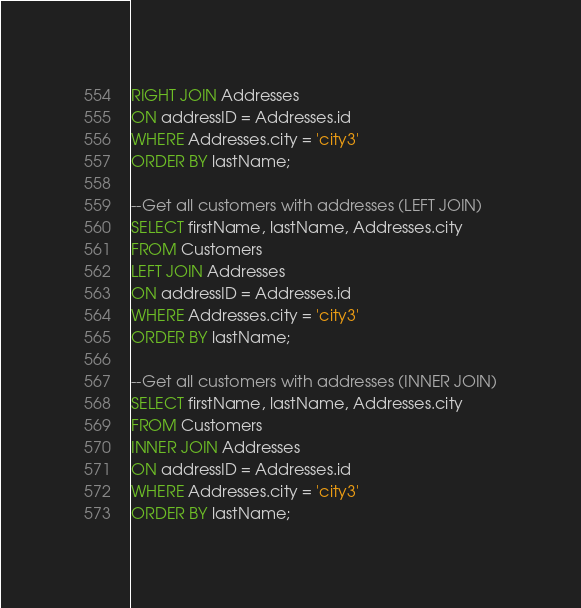Convert code to text. <code><loc_0><loc_0><loc_500><loc_500><_SQL_>RIGHT JOIN Addresses 
ON addressID = Addresses.id
WHERE Addresses.city = 'city3'
ORDER BY lastName;

--Get all customers with addresses (LEFT JOIN)
SELECT firstName, lastName, Addresses.city
FROM Customers
LEFT JOIN Addresses 
ON addressID = Addresses.id
WHERE Addresses.city = 'city3'
ORDER BY lastName;

--Get all customers with addresses (INNER JOIN)
SELECT firstName, lastName, Addresses.city
FROM Customers
INNER JOIN Addresses 
ON addressID = Addresses.id
WHERE Addresses.city = 'city3'
ORDER BY lastName;</code> 